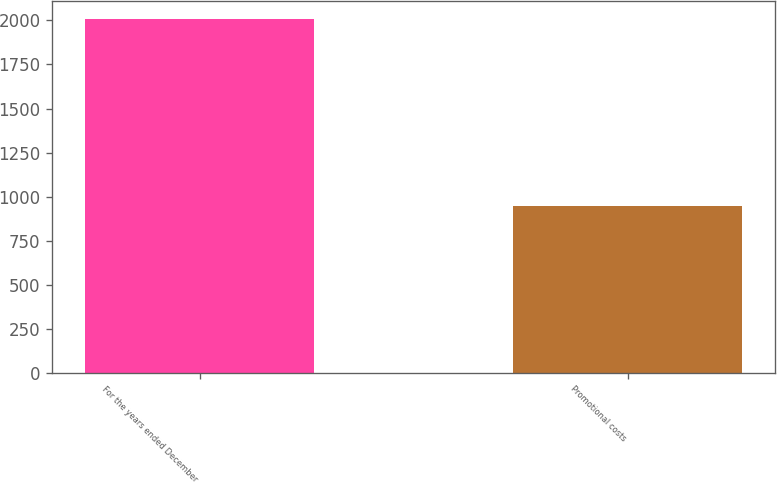Convert chart. <chart><loc_0><loc_0><loc_500><loc_500><bar_chart><fcel>For the years ended December<fcel>Promotional costs<nl><fcel>2011<fcel>945.9<nl></chart> 